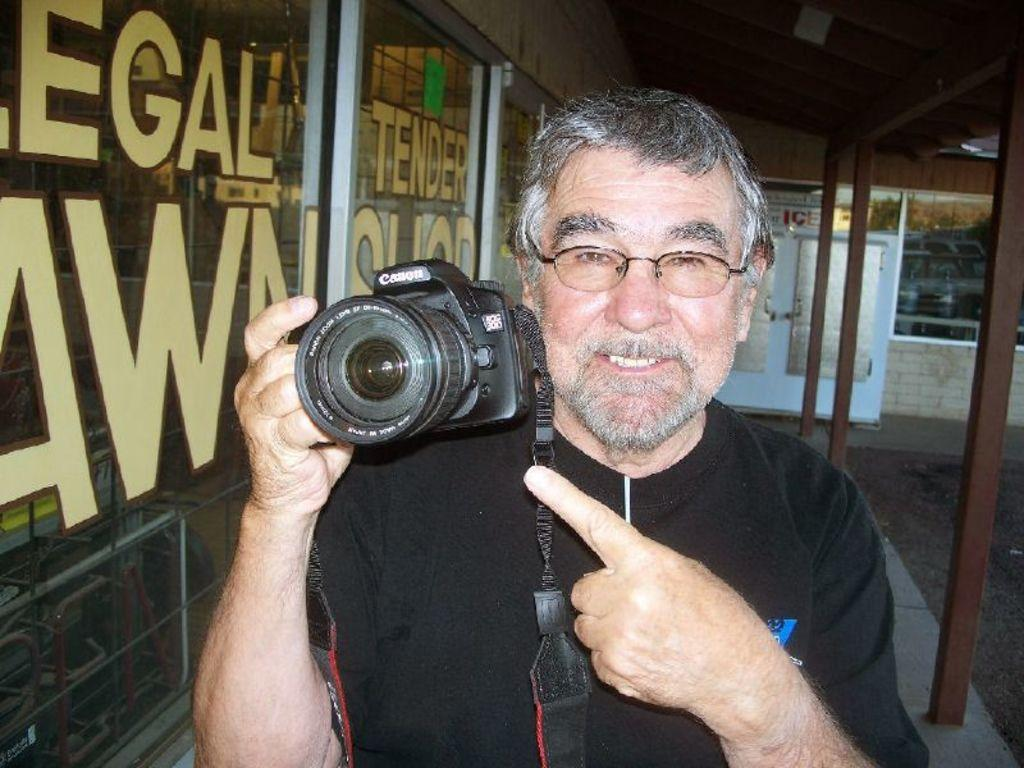Who is present in the image? There is a man in the image. What is the man wearing? The man is wearing a black t-shirt. What is the man holding in the image? The man is holding a camera. What else can be seen in the image besides the man? There is a glass in the image. What can be observed in the reflection of the glass? The glass has a reflection of a vehicle. Where is the swing located in the image? There is no swing present in the image. Can you tell me how many family members are visible in the image? There is no family member present in the image, only a man. What type of hen can be seen in the image? There is no hen present in the image. 